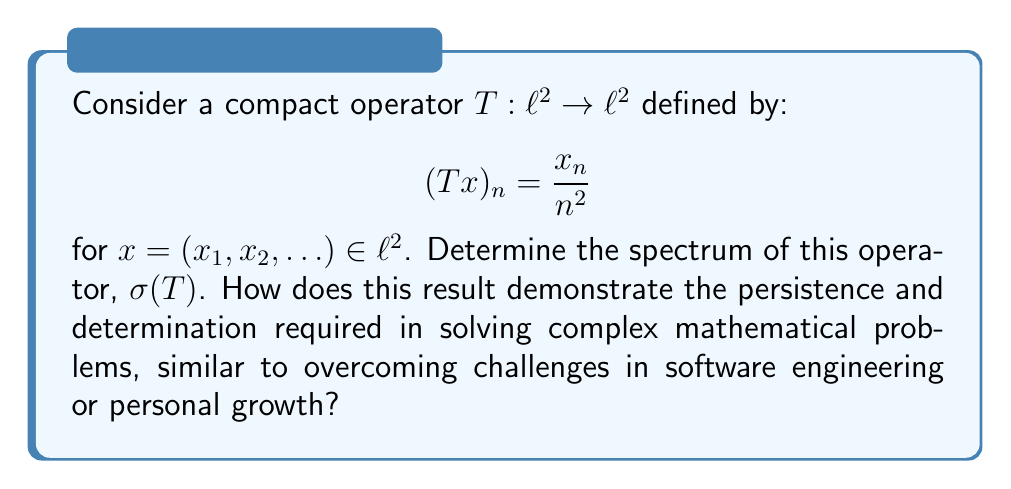Provide a solution to this math problem. Let's approach this step-by-step:

1) First, recall that for a compact operator on a Hilbert space, the spectrum consists of 0 and the eigenvalues of the operator.

2) To find the eigenvalues, we need to solve the equation:

   $Tx = \lambda x$

3) This means:

   $\frac{x_n}{n^2} = \lambda x_n$ for all $n \in \mathbb{N}$

4) If $x_n \neq 0$, we have:

   $\frac{1}{n^2} = \lambda$

5) This gives us potential eigenvalues:

   $\lambda_n = \frac{1}{n^2}$ for $n \in \mathbb{N}$

6) We need to verify that these are indeed eigenvalues. For each $\lambda_n$, the corresponding eigenvector is $e_n$ (the sequence with 1 in the nth position and 0 elsewhere).

7) The sequence of eigenvalues $\{\frac{1}{n^2}\}_{n=1}^{\infty}$ converges to 0.

8) Since T is compact, 0 is also in the spectrum.

9) Therefore, the spectrum of T is:

   $\sigma(T) = \{0\} \cup \{\frac{1}{n^2} : n \in \mathbb{N}\}$

This problem demonstrates persistence and determination in several ways:
- It requires careful analysis and step-by-step reasoning, much like debugging complex software.
- The solution isn't immediately obvious, requiring perseverance to work through each step.
- The infinite nature of the problem mirrors the ongoing challenges in software engineering and personal growth, where there's always more to learn and improve upon.
Answer: $\sigma(T) = \{0\} \cup \{\frac{1}{n^2} : n \in \mathbb{N}\}$ 